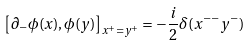<formula> <loc_0><loc_0><loc_500><loc_500>\left [ \partial _ { - } \phi ( x ) , \phi ( y ) \right ] _ { x ^ { + } = y ^ { + } } = - \frac { i } { 2 } \delta ( x ^ { - - } y ^ { - } )</formula> 